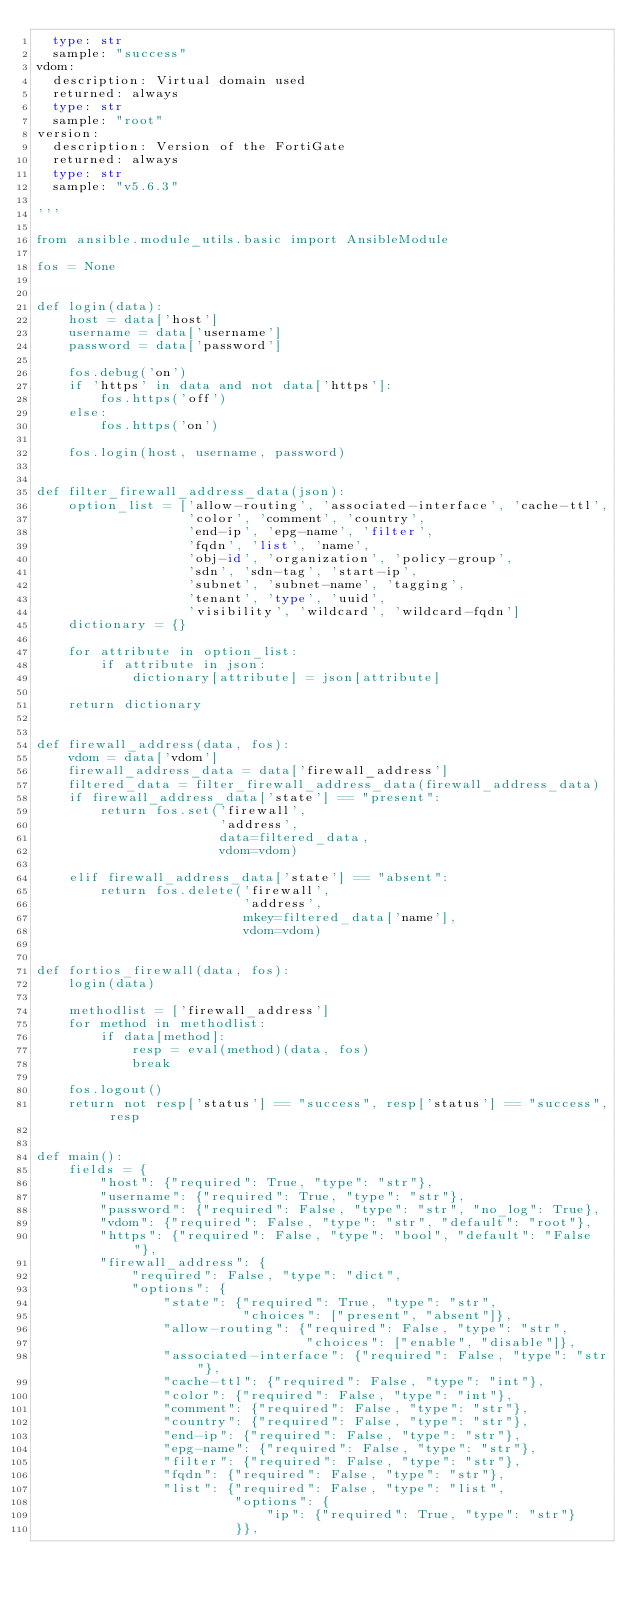<code> <loc_0><loc_0><loc_500><loc_500><_Python_>  type: str
  sample: "success"
vdom:
  description: Virtual domain used
  returned: always
  type: str
  sample: "root"
version:
  description: Version of the FortiGate
  returned: always
  type: str
  sample: "v5.6.3"

'''

from ansible.module_utils.basic import AnsibleModule

fos = None


def login(data):
    host = data['host']
    username = data['username']
    password = data['password']

    fos.debug('on')
    if 'https' in data and not data['https']:
        fos.https('off')
    else:
        fos.https('on')

    fos.login(host, username, password)


def filter_firewall_address_data(json):
    option_list = ['allow-routing', 'associated-interface', 'cache-ttl',
                   'color', 'comment', 'country',
                   'end-ip', 'epg-name', 'filter',
                   'fqdn', 'list', 'name',
                   'obj-id', 'organization', 'policy-group',
                   'sdn', 'sdn-tag', 'start-ip',
                   'subnet', 'subnet-name', 'tagging',
                   'tenant', 'type', 'uuid',
                   'visibility', 'wildcard', 'wildcard-fqdn']
    dictionary = {}

    for attribute in option_list:
        if attribute in json:
            dictionary[attribute] = json[attribute]

    return dictionary


def firewall_address(data, fos):
    vdom = data['vdom']
    firewall_address_data = data['firewall_address']
    filtered_data = filter_firewall_address_data(firewall_address_data)
    if firewall_address_data['state'] == "present":
        return fos.set('firewall',
                       'address',
                       data=filtered_data,
                       vdom=vdom)

    elif firewall_address_data['state'] == "absent":
        return fos.delete('firewall',
                          'address',
                          mkey=filtered_data['name'],
                          vdom=vdom)


def fortios_firewall(data, fos):
    login(data)

    methodlist = ['firewall_address']
    for method in methodlist:
        if data[method]:
            resp = eval(method)(data, fos)
            break

    fos.logout()
    return not resp['status'] == "success", resp['status'] == "success", resp


def main():
    fields = {
        "host": {"required": True, "type": "str"},
        "username": {"required": True, "type": "str"},
        "password": {"required": False, "type": "str", "no_log": True},
        "vdom": {"required": False, "type": "str", "default": "root"},
        "https": {"required": False, "type": "bool", "default": "False"},
        "firewall_address": {
            "required": False, "type": "dict",
            "options": {
                "state": {"required": True, "type": "str",
                          "choices": ["present", "absent"]},
                "allow-routing": {"required": False, "type": "str",
                                  "choices": ["enable", "disable"]},
                "associated-interface": {"required": False, "type": "str"},
                "cache-ttl": {"required": False, "type": "int"},
                "color": {"required": False, "type": "int"},
                "comment": {"required": False, "type": "str"},
                "country": {"required": False, "type": "str"},
                "end-ip": {"required": False, "type": "str"},
                "epg-name": {"required": False, "type": "str"},
                "filter": {"required": False, "type": "str"},
                "fqdn": {"required": False, "type": "str"},
                "list": {"required": False, "type": "list",
                         "options": {
                             "ip": {"required": True, "type": "str"}
                         }},</code> 